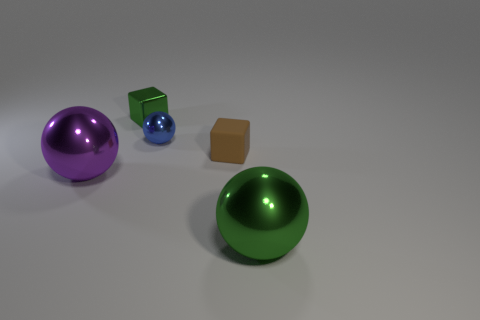Does the tiny metal cube have the same color as the metallic object that is on the right side of the small blue shiny thing?
Your answer should be very brief. Yes. There is a blue metal sphere; does it have the same size as the brown block behind the big green metallic thing?
Provide a succinct answer. Yes. What number of other objects are the same color as the shiny block?
Give a very brief answer. 1. Are there more small blue shiny spheres that are left of the brown object than red shiny objects?
Your answer should be very brief. Yes. There is a large metal ball to the left of the green metallic thing that is behind the big object in front of the large purple thing; what color is it?
Your response must be concise. Purple. Are the tiny green block and the large green sphere made of the same material?
Keep it short and to the point. Yes. Are there any other blue shiny things of the same size as the blue object?
Your response must be concise. No. What is the material of the ball that is the same size as the shiny block?
Ensure brevity in your answer.  Metal. Is there a big green metallic object of the same shape as the brown thing?
Give a very brief answer. No. There is a large sphere that is the same color as the tiny metal cube; what is it made of?
Ensure brevity in your answer.  Metal. 